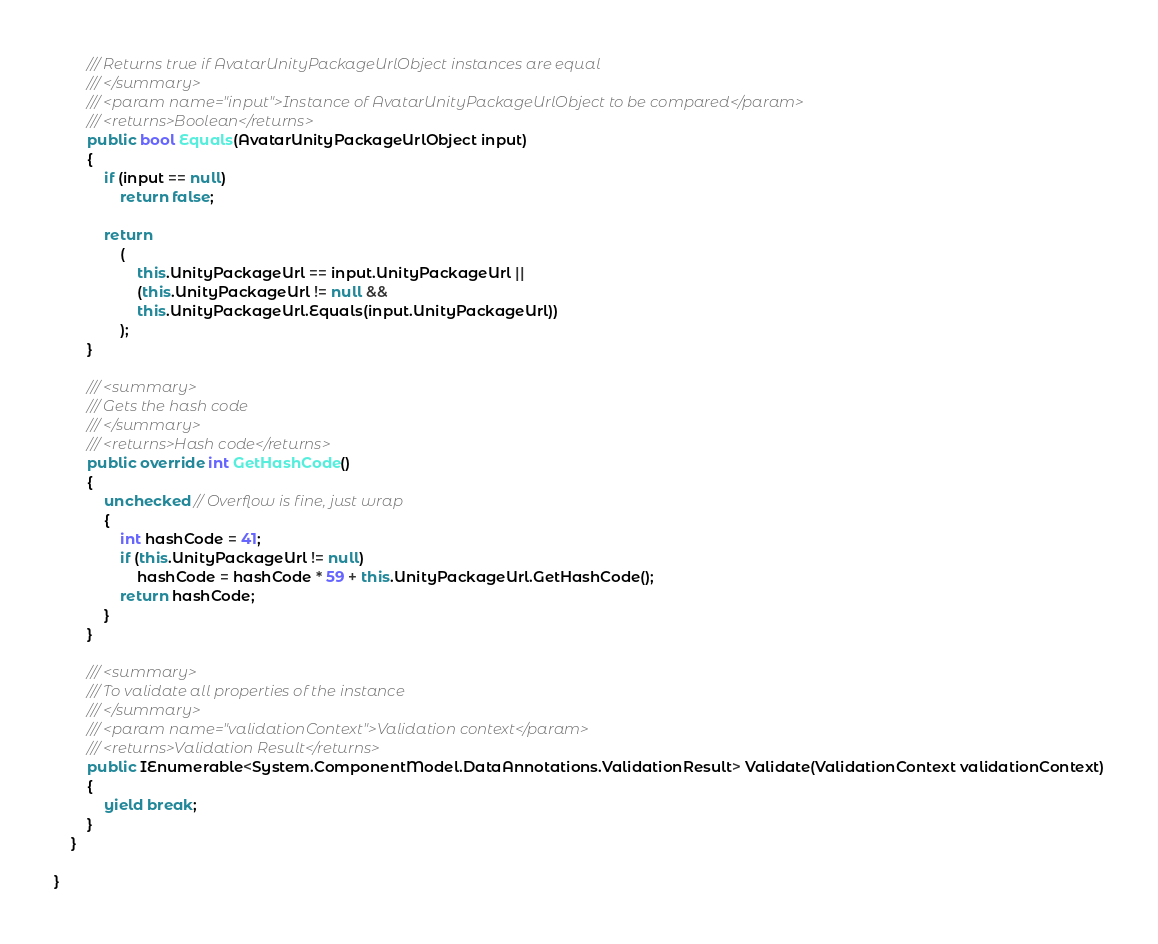Convert code to text. <code><loc_0><loc_0><loc_500><loc_500><_C#_>        /// Returns true if AvatarUnityPackageUrlObject instances are equal
        /// </summary>
        /// <param name="input">Instance of AvatarUnityPackageUrlObject to be compared</param>
        /// <returns>Boolean</returns>
        public bool Equals(AvatarUnityPackageUrlObject input)
        {
            if (input == null)
                return false;

            return 
                (
                    this.UnityPackageUrl == input.UnityPackageUrl ||
                    (this.UnityPackageUrl != null &&
                    this.UnityPackageUrl.Equals(input.UnityPackageUrl))
                );
        }

        /// <summary>
        /// Gets the hash code
        /// </summary>
        /// <returns>Hash code</returns>
        public override int GetHashCode()
        {
            unchecked // Overflow is fine, just wrap
            {
                int hashCode = 41;
                if (this.UnityPackageUrl != null)
                    hashCode = hashCode * 59 + this.UnityPackageUrl.GetHashCode();
                return hashCode;
            }
        }

        /// <summary>
        /// To validate all properties of the instance
        /// </summary>
        /// <param name="validationContext">Validation context</param>
        /// <returns>Validation Result</returns>
        public IEnumerable<System.ComponentModel.DataAnnotations.ValidationResult> Validate(ValidationContext validationContext)
        {
            yield break;
        }
    }

}
</code> 